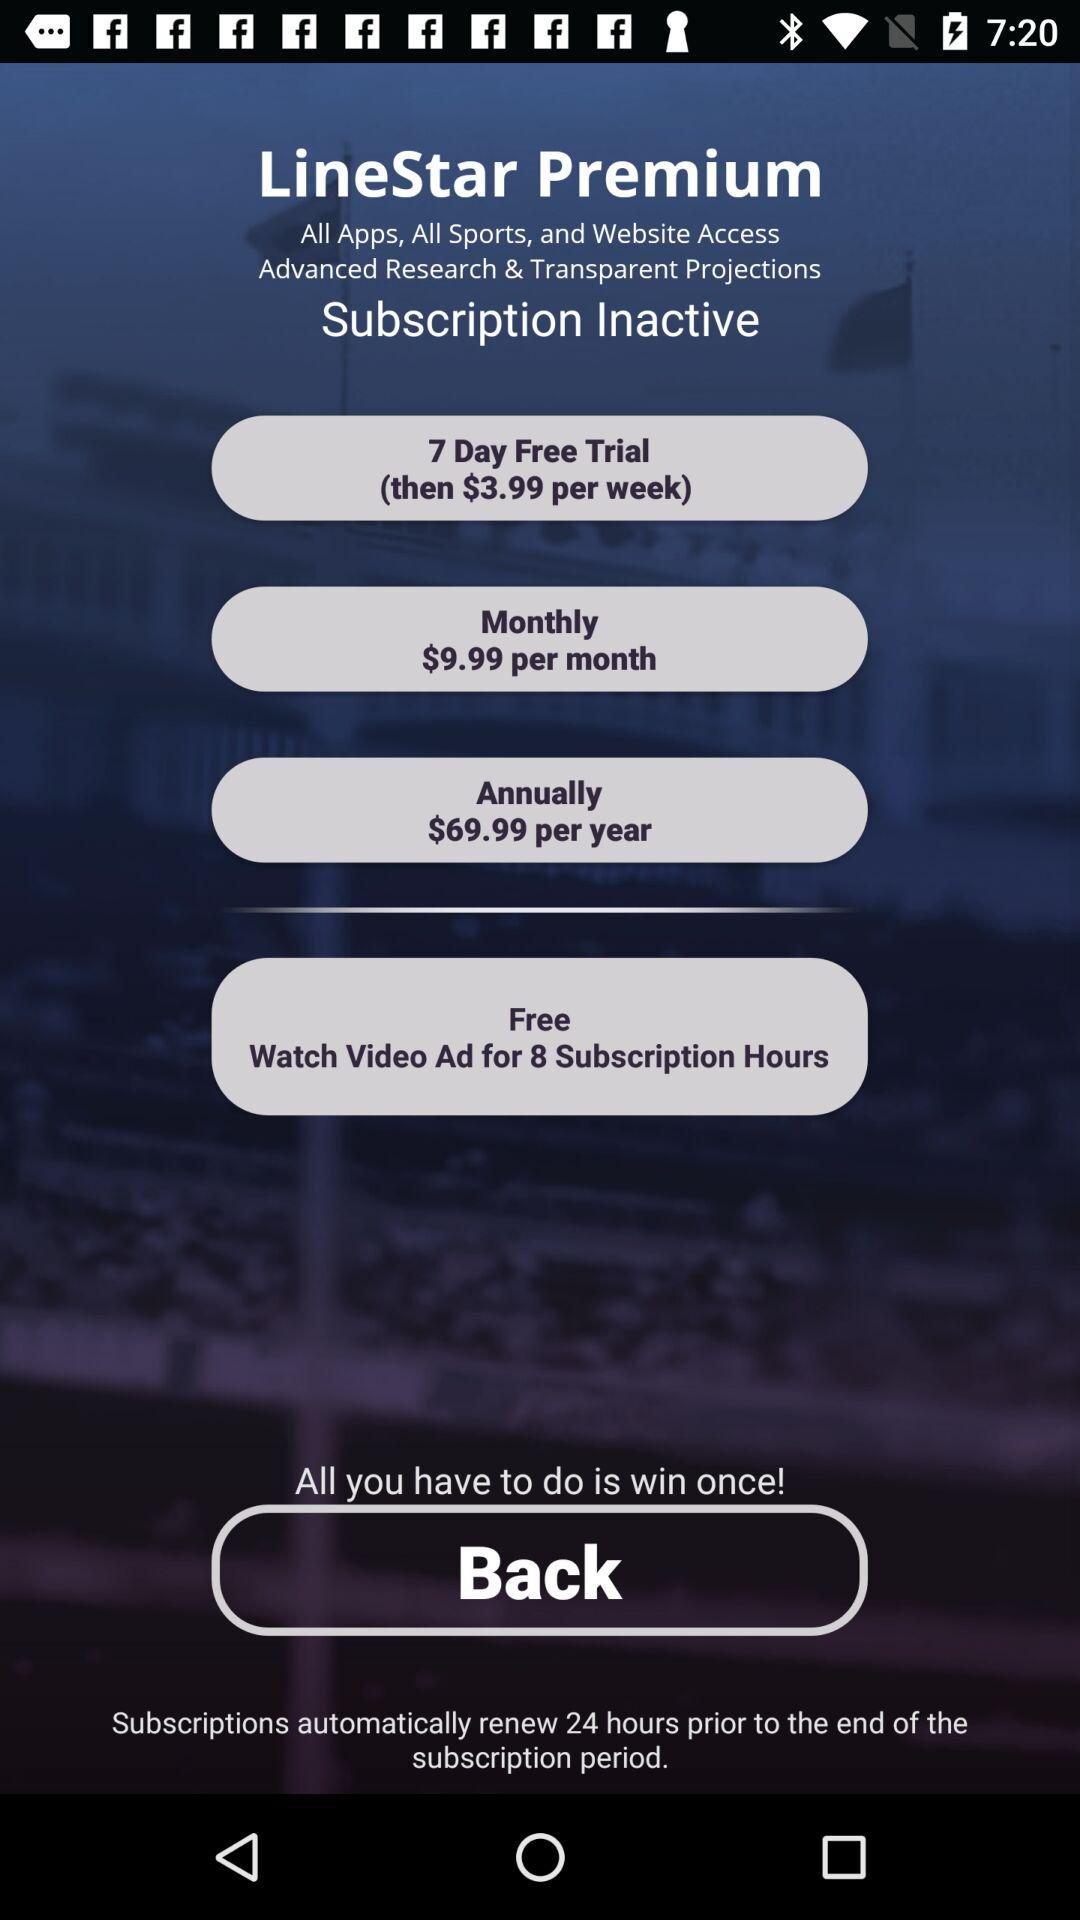What is the app name? The app name is "LineStar Premium". 